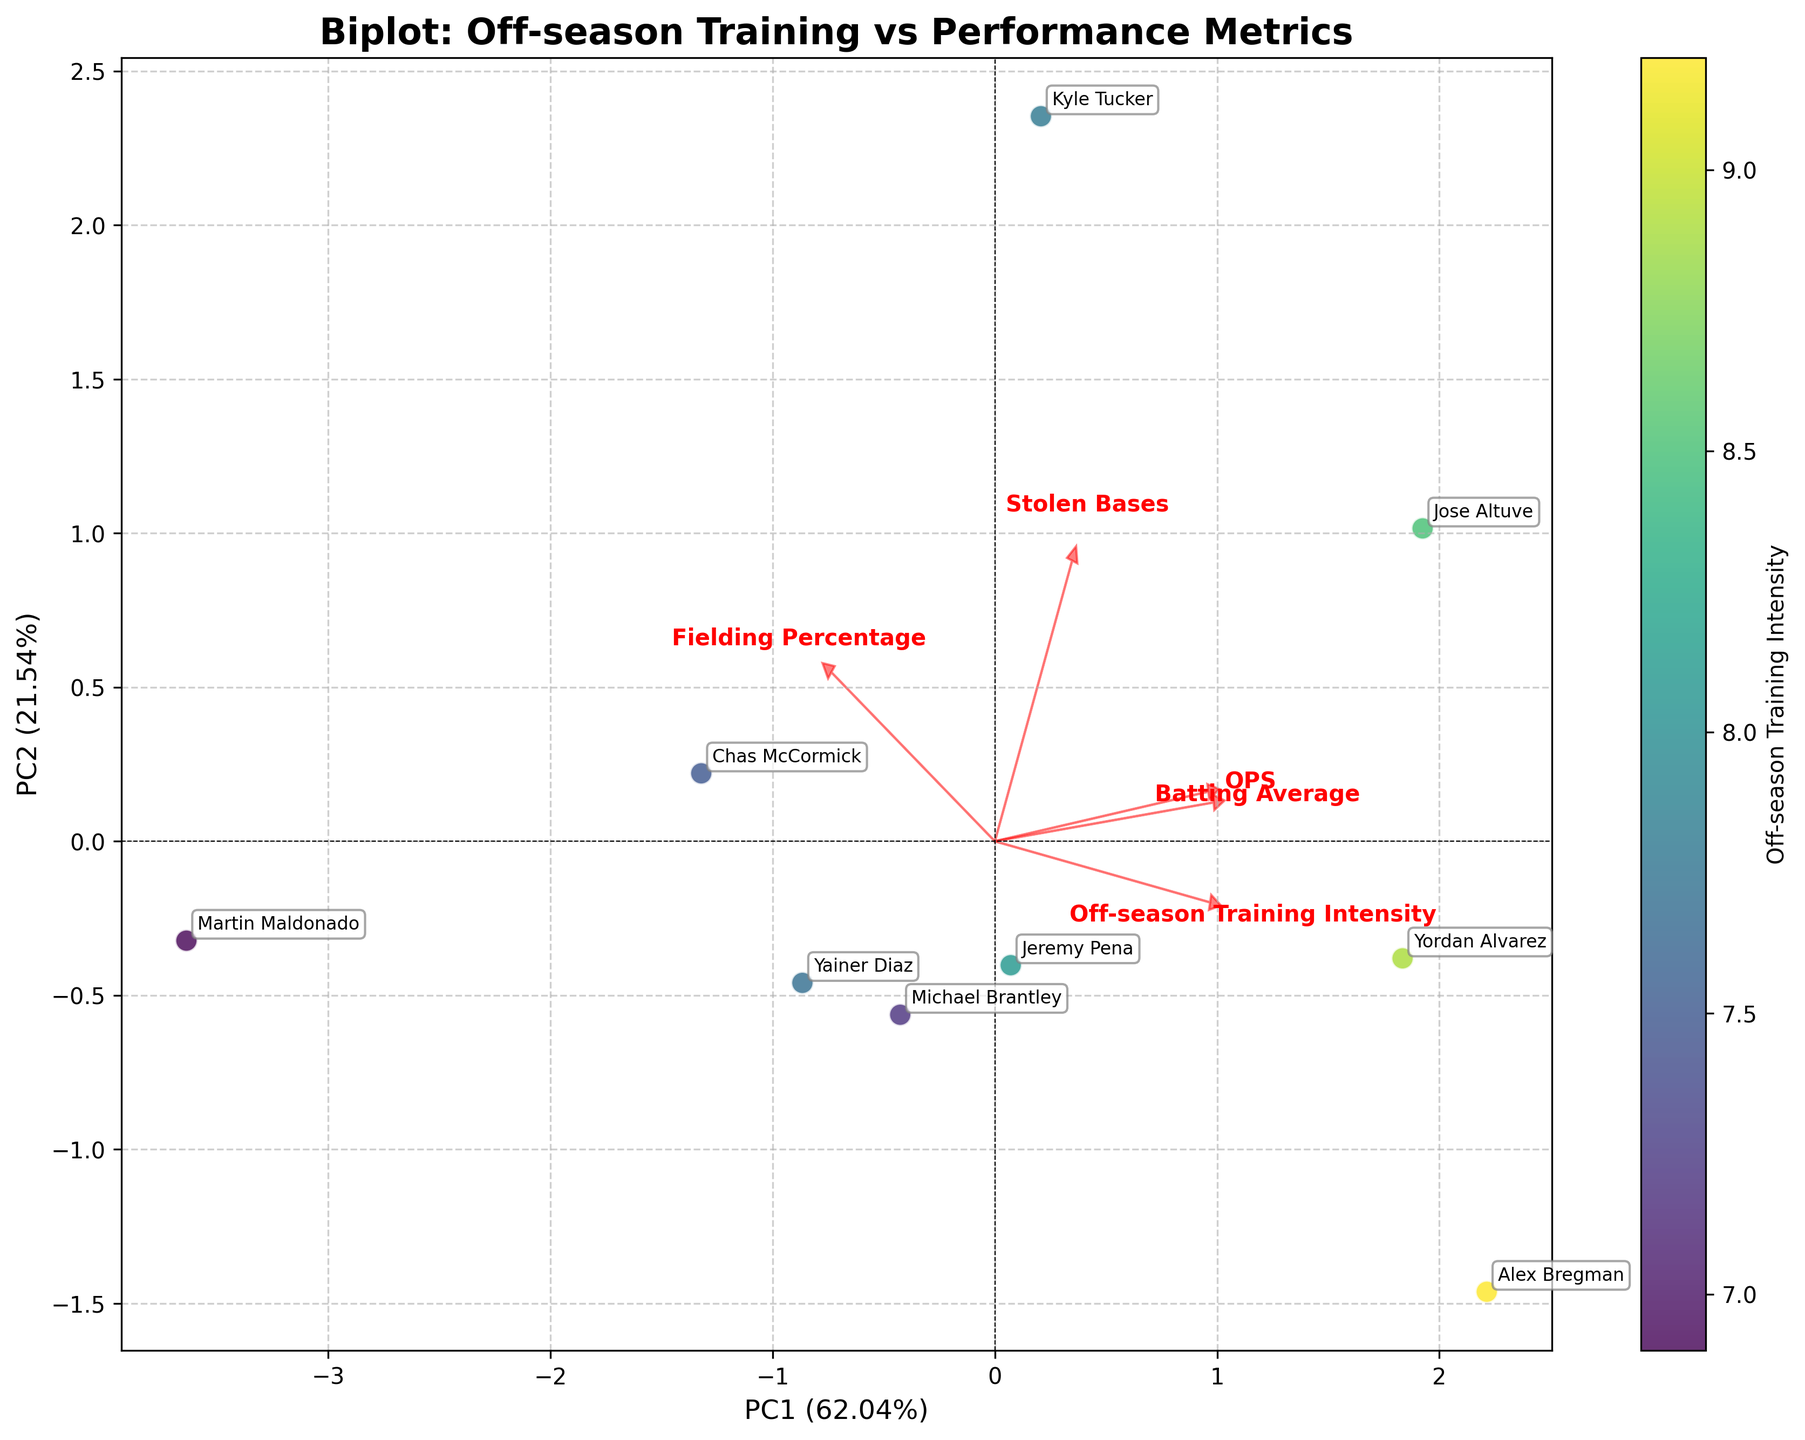What do the arrows in the biplot represent? The arrows in the biplot represent the loadings of the variables onto the principal components. They show the direction and magnitude of each variable's contribution to the principal components.
Answer: Loadings of variables Which player has the highest off-season training intensity? By looking at the color intensity in the scatter plot, which represents off-season training intensity, Alex Bregman appears to have the highest intensity, indicated by the most intense color.
Answer: Alex Bregman What is the relationship between Batting Average and Fielding Percentage based on their loadings? The arrows for Batting Average and Fielding Percentage are almost orthogonal (perpendicular) to each other, which suggests that these two metrics are not strongly correlated in the biplot.
Answer: Not strongly correlated Which performance metric is most associated with PC1 in the biplot? The arrow with the greatest projection along the PC1 axis indicates which performance metric is most associated with PC1. Batting Average seems to have the strongest loading in the direction of PC1.
Answer: Batting Average Which player is located furthest from the origin in the biplot, and what does this signify? Jose Altuve is located furthest from the origin, which indicates he has the most extreme values for the principal components and thereby has unique patterns in his performance metrics and off-season training intensity.
Answer: Jose Altuve Do any players have negative values for both PC1 and PC2? If so, who? A player with both coordinates in the negative quadrant on the biplot will have negative values for PC1 and PC2. Martin Maldonado appears to be in this quadrant.
Answer: Martin Maldonado How much variance is explained by the first principal component (PC1)? This information is available on the label of the x-axis, which shows the percentage of variance explained.
Answer: Look at the x-axis label in the biplot, It provides the exact amount of variance explained by PC1 Which two players have the closest principal component scores on the biplot? By examining the proximity of the points, Michael Brantley and Yainer Diaz appear to have the closest principal component scores in the plot.
Answer: Michael Brantley and Yainer Diaz Between Off-season Training Intensity and Stolen Bases, which metric has a stronger influence on the second principal component (PC2)? Compare the lengths and directions of the arrows. The arrow for Stolen Bases has a substantial projection on the PC2 axis, suggesting it has a stronger influence compared to Off-season Training Intensity.
Answer: Stolen Bases 